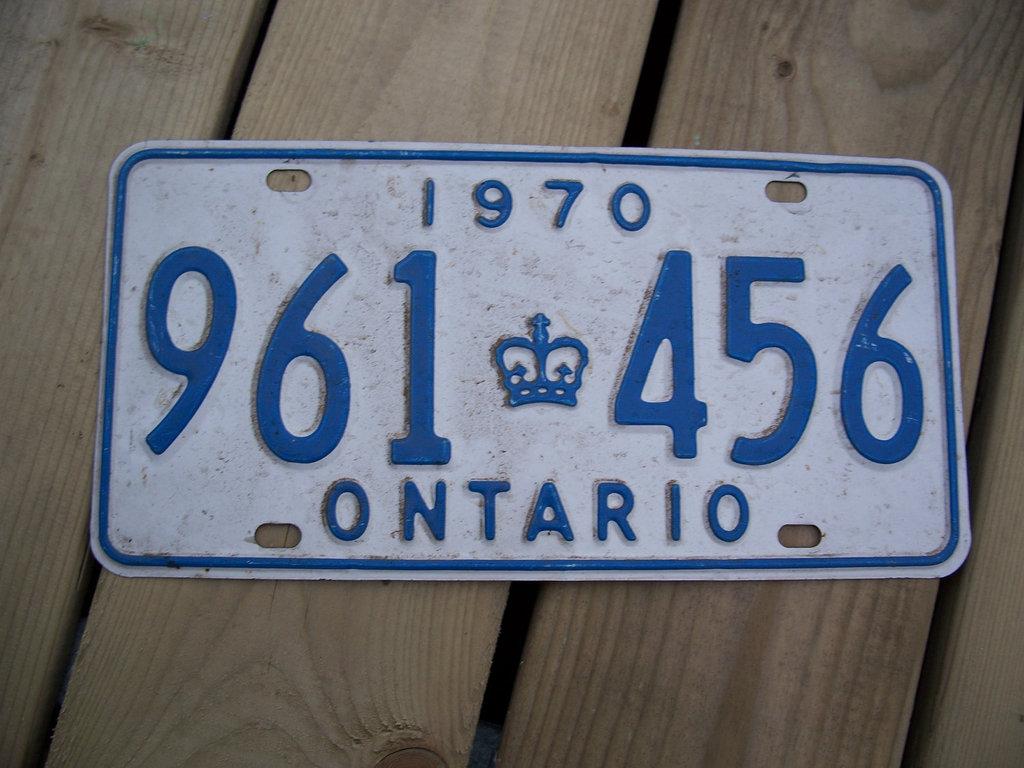What is the number on that building?
Offer a terse response. Unanswerable. What year is on the plate?
Give a very brief answer. 1970. 